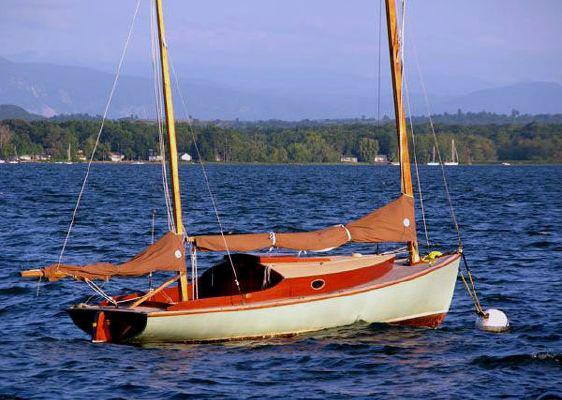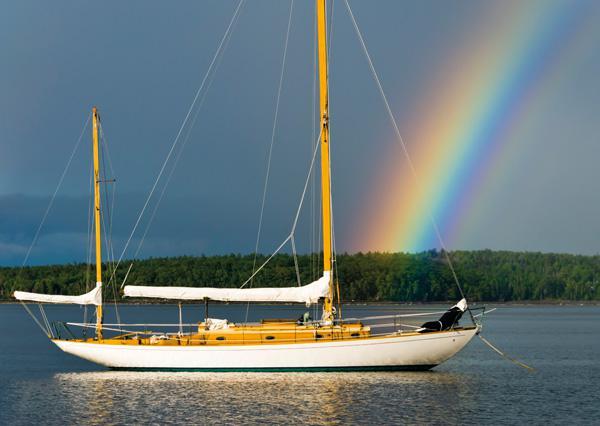The first image is the image on the left, the second image is the image on the right. Evaluate the accuracy of this statement regarding the images: "The sails on both of the sailboats are furled.". Is it true? Answer yes or no. Yes. 